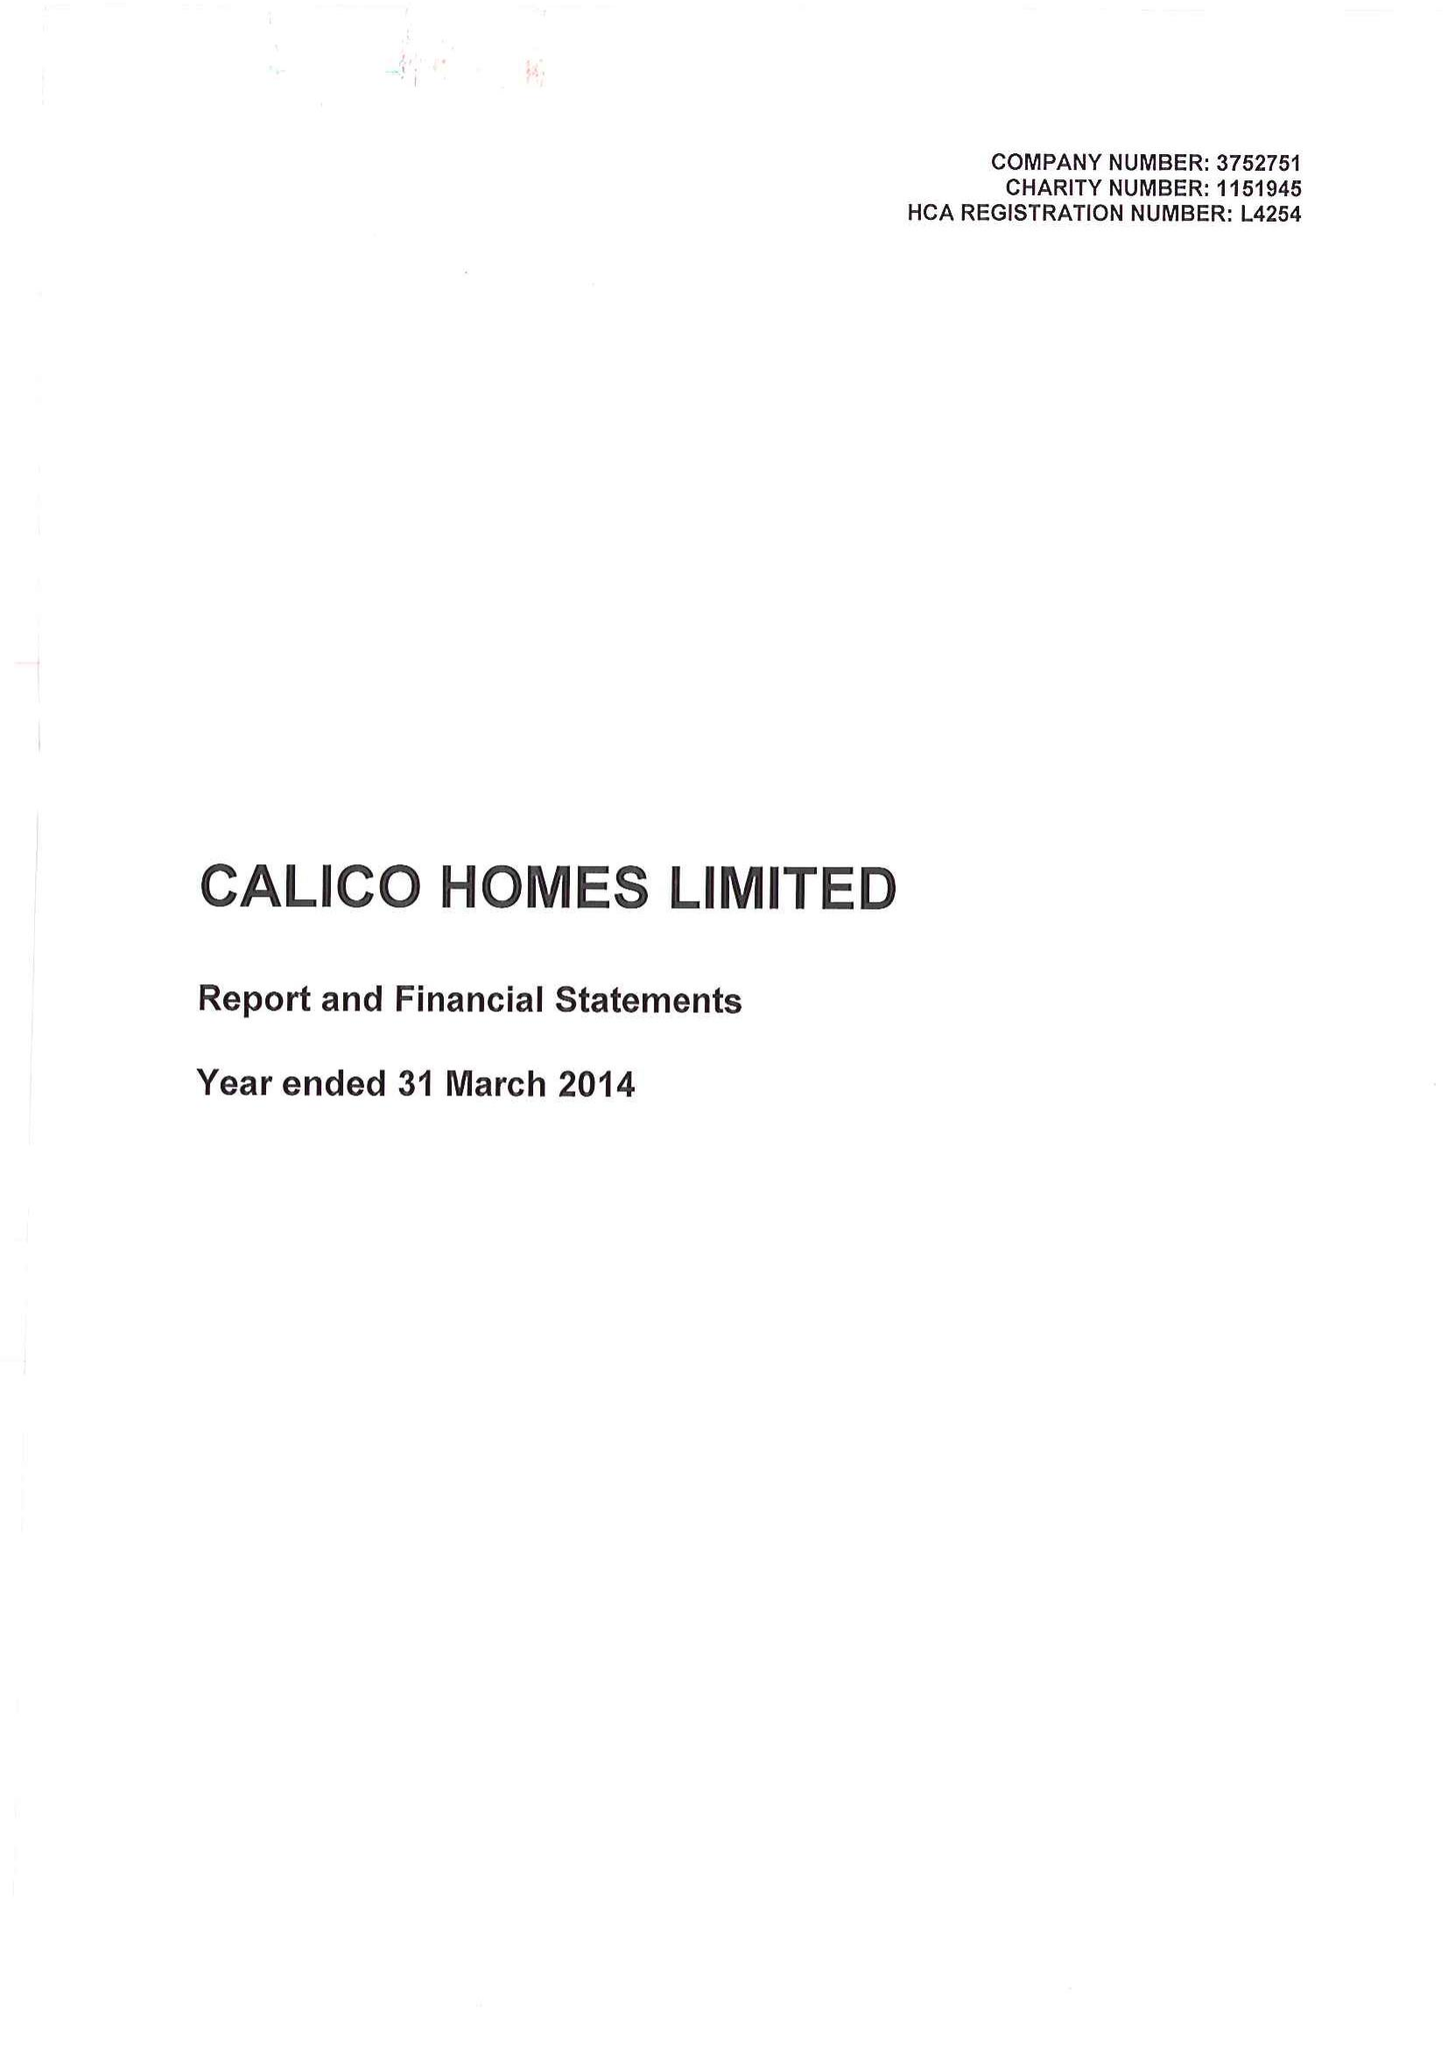What is the value for the address__postcode?
Answer the question using a single word or phrase. BB11 2ED 